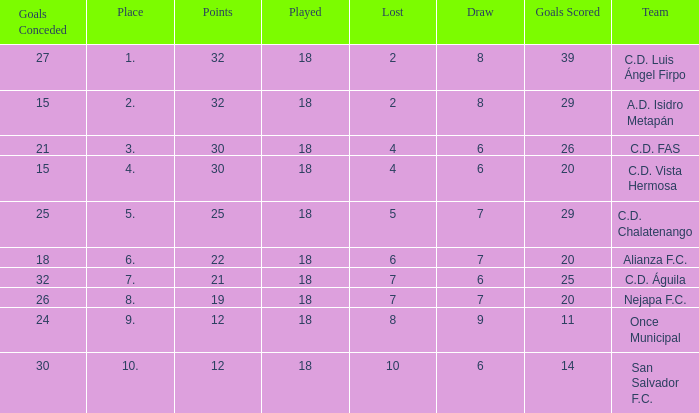What is the lowest played with a lost bigger than 10? None. 